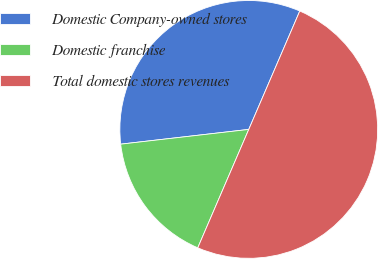Convert chart to OTSL. <chart><loc_0><loc_0><loc_500><loc_500><pie_chart><fcel>Domestic Company-owned stores<fcel>Domestic franchise<fcel>Total domestic stores revenues<nl><fcel>33.3%<fcel>16.7%<fcel>50.0%<nl></chart> 